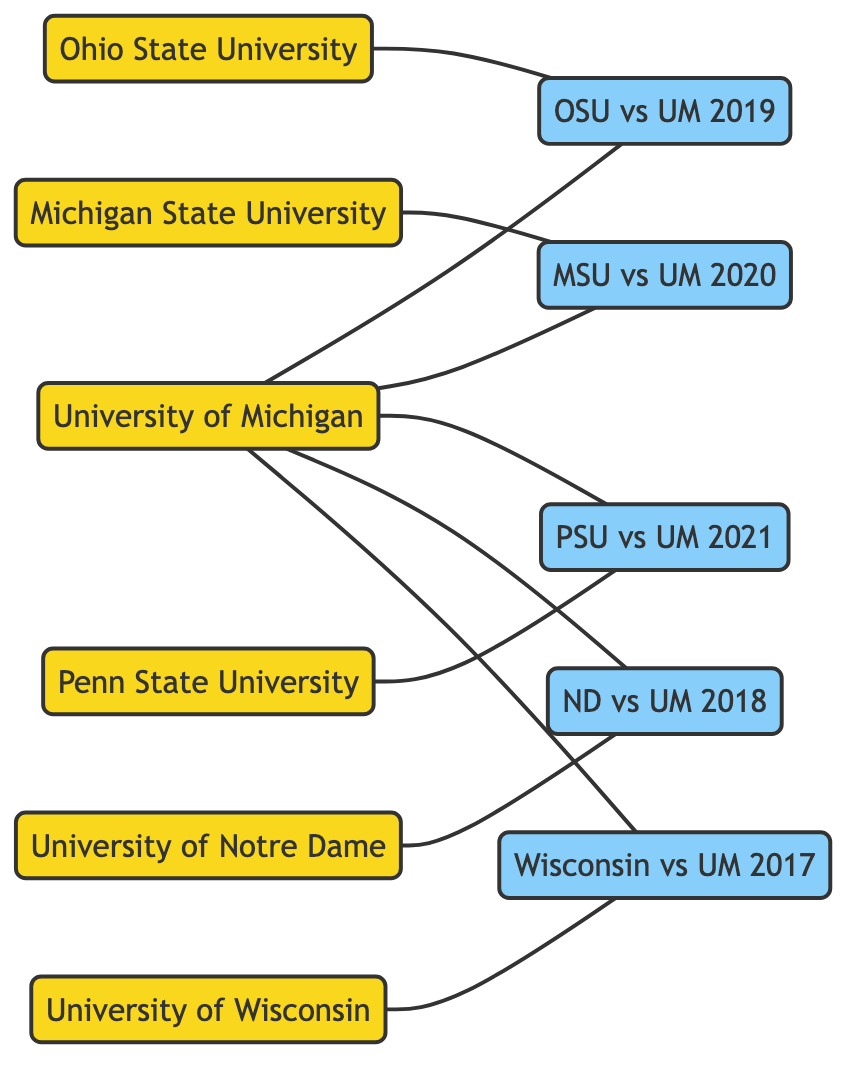What is the total number of teams represented in the diagram? The diagram explicitly lists six teams: University of Michigan, Ohio State University, Michigan State University, Penn State University, University of Notre Dame, and University of Wisconsin. Counting these gives a total of six teams.
Answer: 6 Which game involved Ohio State University? The edge connected to the node "Ohio State University" leads directly to the node "OSU vs UM 2019", indicating that this game involved Ohio State University.
Answer: OSU vs UM 2019 How many games did the University of Michigan play in the last decade? The University of Michigan is connected to five games: OSU vs UM 2019, MSU vs UM 2020, PSU vs UM 2021, ND vs UM 2018, and Wisconsin vs UM 2017. Counting these connections gives a total of five games played.
Answer: 5 What is the relationship between University of Michigan and Michigan State University? The diagram shows an edge connecting the node "University of Michigan" to the node "MSU vs UM 2020", representing a game played between them, indicating a direct rivalry.
Answer: played Which team played against Notre Dame in the diagram? The edge connected to the Notre Dame node leads to the game "ND vs UM 2018", showing that the University of Michigan played against Notre Dame.
Answer: University of Michigan Which two teams have played a game with University of Michigan in 2017? The University of Michigan is connected to the game labeled "Wisconsin vs UM 2017", and the connection shows Wisconsin as the other team. Therefore, Wisconsin played against University of Michigan that year.
Answer: Wisconsin How many games are represented in this network diagram? The diagram showcases five distinct game nodes: OSU vs UM 2019, MSU vs UM 2020, PSU vs UM 2021, ND vs UM 2018, and Wisconsin vs UM 2017. Counting these nodes results in five games represented in the network.
Answer: 5 Which team has the most games played against University of Michigan in the last decade? Upon analyzing the connections, University of Michigan played against Ohio State, Michigan State, Penn State, Notre Dame, and Wisconsin once each, summing to equal games, thus no team stands out with more games.
Answer: Equal (1 game each) 